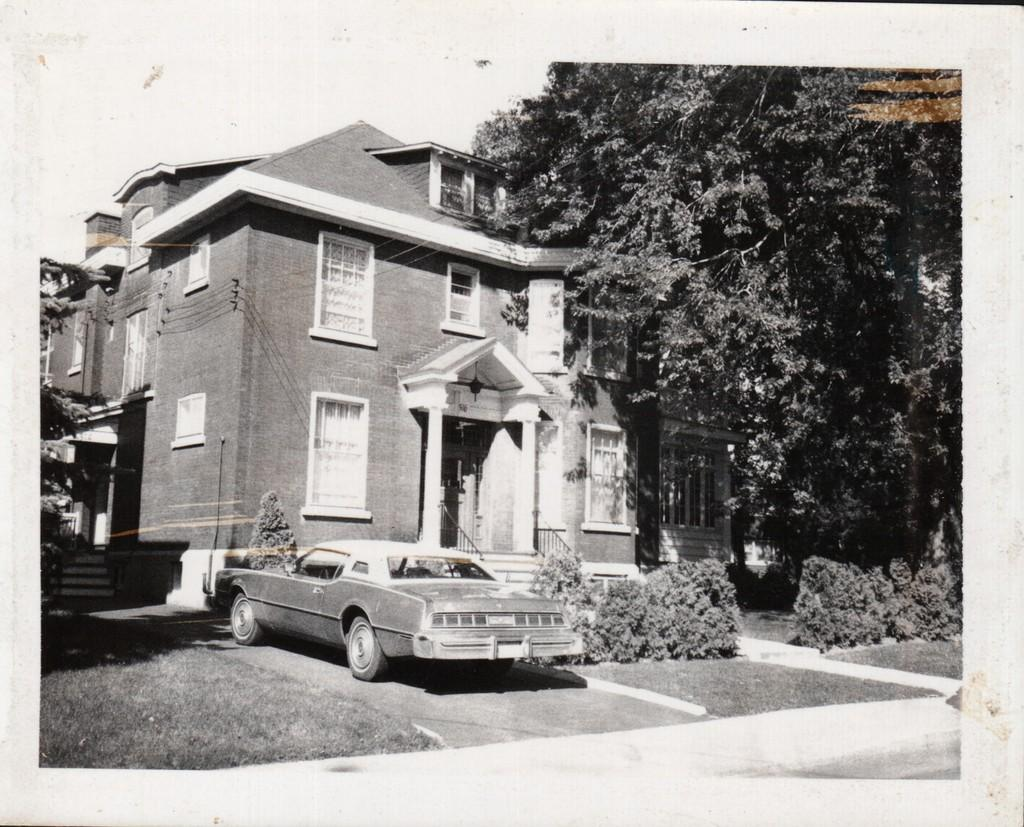What is the main structure visible in the image? There is a building in the image. Is there any vehicle parked near the building? Yes, a car is parked in front of the building. What type of vegetation can be seen at the right side of the image? There are trees present at the right side of the image. What type of waves can be seen crashing against the building in the image? There are no waves present in the image; it features a building with a parked car and trees. Is there any competition taking place in front of the building in the image? There is no competition visible in the image; it only shows a building, a parked car, and trees. 